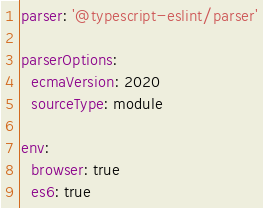Convert code to text. <code><loc_0><loc_0><loc_500><loc_500><_YAML_>parser: '@typescript-eslint/parser'

parserOptions:
  ecmaVersion: 2020
  sourceType: module

env:
  browser: true
  es6: true</code> 